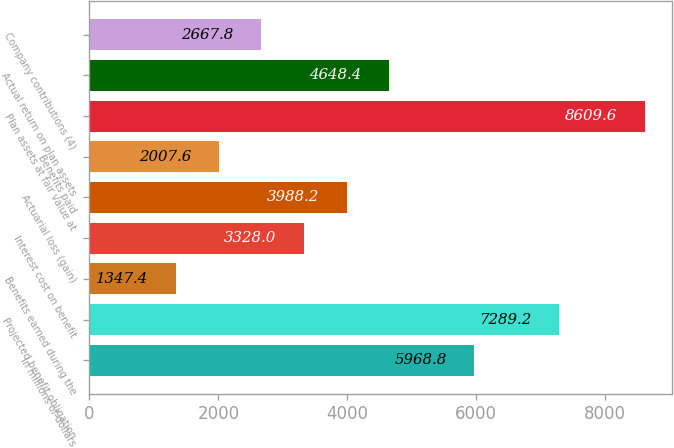<chart> <loc_0><loc_0><loc_500><loc_500><bar_chart><fcel>In millions of dollars<fcel>Projected benefit obligation<fcel>Benefits earned during the<fcel>Interest cost on benefit<fcel>Actuarial loss (gain)<fcel>Benefits paid<fcel>Plan assets at fair value at<fcel>Actual return on plan assets<fcel>Company contributions (4)<nl><fcel>5968.8<fcel>7289.2<fcel>1347.4<fcel>3328<fcel>3988.2<fcel>2007.6<fcel>8609.6<fcel>4648.4<fcel>2667.8<nl></chart> 